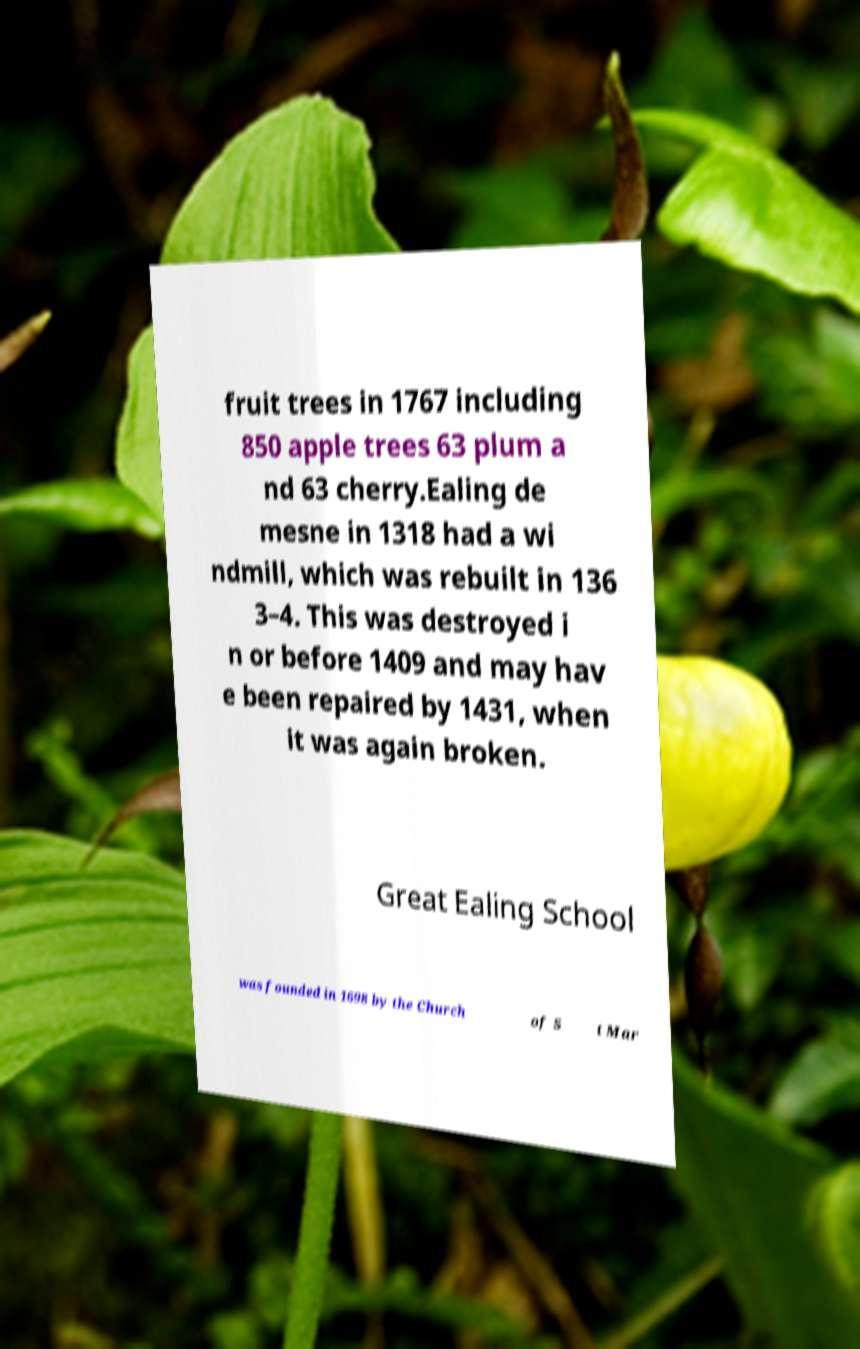What messages or text are displayed in this image? I need them in a readable, typed format. fruit trees in 1767 including 850 apple trees 63 plum a nd 63 cherry.Ealing de mesne in 1318 had a wi ndmill, which was rebuilt in 136 3–4. This was destroyed i n or before 1409 and may hav e been repaired by 1431, when it was again broken. Great Ealing School was founded in 1698 by the Church of S t Mar 